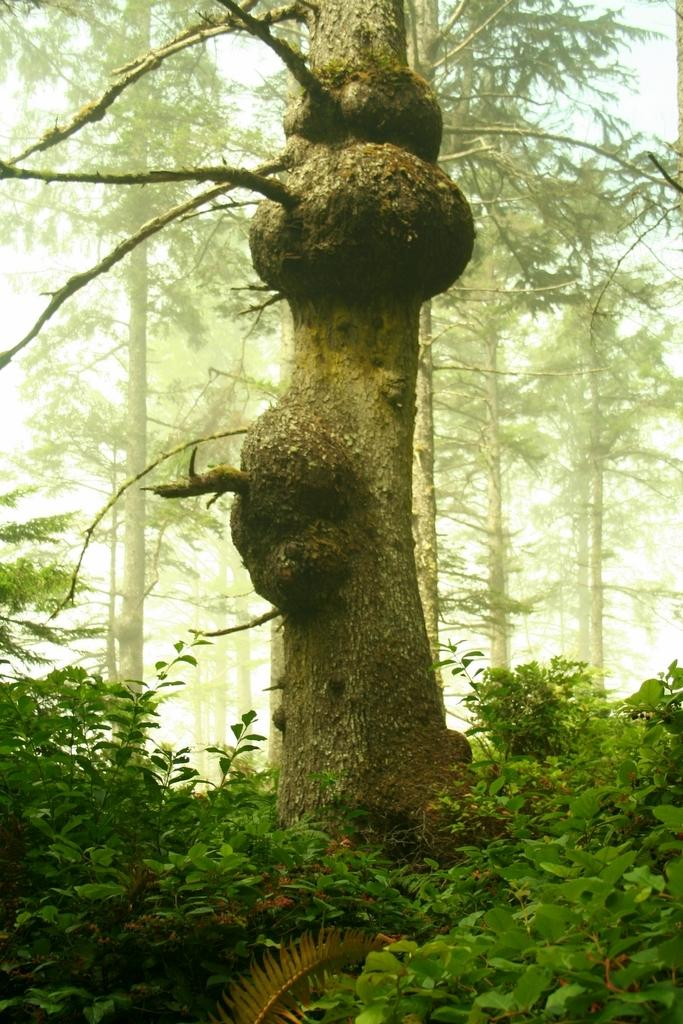What is the main subject of the image? The main subject of the image is a tree trunk. What else can be seen around the tree trunk? There are plants around the tree trunk. What can be seen in the distance in the image? There are trees visible in the background of the image. What type of shoes can be seen hanging from the tree trunk in the image? There are no shoes present in the image; it only features a tree trunk, plants, and trees in the background. 